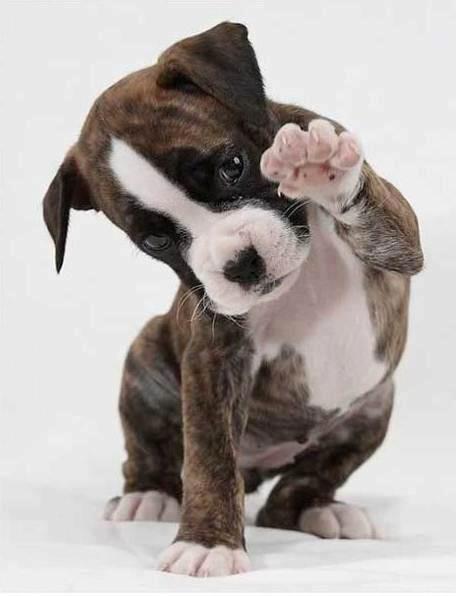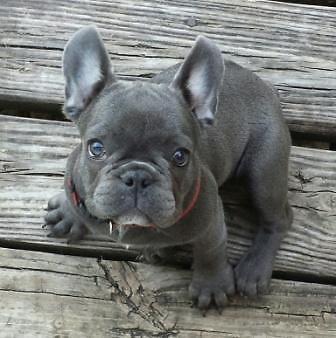The first image is the image on the left, the second image is the image on the right. For the images shown, is this caption "At least one dog is sleeping next to a human." true? Answer yes or no. No. The first image is the image on the left, the second image is the image on the right. For the images displayed, is the sentence "An adult human is holding one of the dogs." factually correct? Answer yes or no. No. 